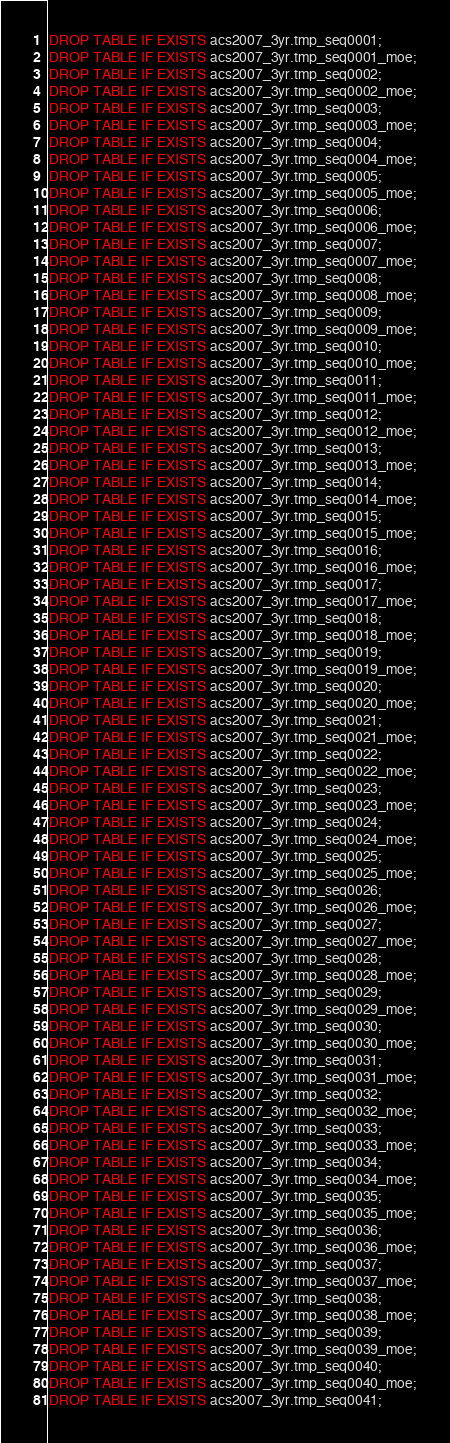<code> <loc_0><loc_0><loc_500><loc_500><_SQL_>DROP TABLE IF EXISTS acs2007_3yr.tmp_seq0001;
DROP TABLE IF EXISTS acs2007_3yr.tmp_seq0001_moe;
DROP TABLE IF EXISTS acs2007_3yr.tmp_seq0002;
DROP TABLE IF EXISTS acs2007_3yr.tmp_seq0002_moe;
DROP TABLE IF EXISTS acs2007_3yr.tmp_seq0003;
DROP TABLE IF EXISTS acs2007_3yr.tmp_seq0003_moe;
DROP TABLE IF EXISTS acs2007_3yr.tmp_seq0004;
DROP TABLE IF EXISTS acs2007_3yr.tmp_seq0004_moe;
DROP TABLE IF EXISTS acs2007_3yr.tmp_seq0005;
DROP TABLE IF EXISTS acs2007_3yr.tmp_seq0005_moe;
DROP TABLE IF EXISTS acs2007_3yr.tmp_seq0006;
DROP TABLE IF EXISTS acs2007_3yr.tmp_seq0006_moe;
DROP TABLE IF EXISTS acs2007_3yr.tmp_seq0007;
DROP TABLE IF EXISTS acs2007_3yr.tmp_seq0007_moe;
DROP TABLE IF EXISTS acs2007_3yr.tmp_seq0008;
DROP TABLE IF EXISTS acs2007_3yr.tmp_seq0008_moe;
DROP TABLE IF EXISTS acs2007_3yr.tmp_seq0009;
DROP TABLE IF EXISTS acs2007_3yr.tmp_seq0009_moe;
DROP TABLE IF EXISTS acs2007_3yr.tmp_seq0010;
DROP TABLE IF EXISTS acs2007_3yr.tmp_seq0010_moe;
DROP TABLE IF EXISTS acs2007_3yr.tmp_seq0011;
DROP TABLE IF EXISTS acs2007_3yr.tmp_seq0011_moe;
DROP TABLE IF EXISTS acs2007_3yr.tmp_seq0012;
DROP TABLE IF EXISTS acs2007_3yr.tmp_seq0012_moe;
DROP TABLE IF EXISTS acs2007_3yr.tmp_seq0013;
DROP TABLE IF EXISTS acs2007_3yr.tmp_seq0013_moe;
DROP TABLE IF EXISTS acs2007_3yr.tmp_seq0014;
DROP TABLE IF EXISTS acs2007_3yr.tmp_seq0014_moe;
DROP TABLE IF EXISTS acs2007_3yr.tmp_seq0015;
DROP TABLE IF EXISTS acs2007_3yr.tmp_seq0015_moe;
DROP TABLE IF EXISTS acs2007_3yr.tmp_seq0016;
DROP TABLE IF EXISTS acs2007_3yr.tmp_seq0016_moe;
DROP TABLE IF EXISTS acs2007_3yr.tmp_seq0017;
DROP TABLE IF EXISTS acs2007_3yr.tmp_seq0017_moe;
DROP TABLE IF EXISTS acs2007_3yr.tmp_seq0018;
DROP TABLE IF EXISTS acs2007_3yr.tmp_seq0018_moe;
DROP TABLE IF EXISTS acs2007_3yr.tmp_seq0019;
DROP TABLE IF EXISTS acs2007_3yr.tmp_seq0019_moe;
DROP TABLE IF EXISTS acs2007_3yr.tmp_seq0020;
DROP TABLE IF EXISTS acs2007_3yr.tmp_seq0020_moe;
DROP TABLE IF EXISTS acs2007_3yr.tmp_seq0021;
DROP TABLE IF EXISTS acs2007_3yr.tmp_seq0021_moe;
DROP TABLE IF EXISTS acs2007_3yr.tmp_seq0022;
DROP TABLE IF EXISTS acs2007_3yr.tmp_seq0022_moe;
DROP TABLE IF EXISTS acs2007_3yr.tmp_seq0023;
DROP TABLE IF EXISTS acs2007_3yr.tmp_seq0023_moe;
DROP TABLE IF EXISTS acs2007_3yr.tmp_seq0024;
DROP TABLE IF EXISTS acs2007_3yr.tmp_seq0024_moe;
DROP TABLE IF EXISTS acs2007_3yr.tmp_seq0025;
DROP TABLE IF EXISTS acs2007_3yr.tmp_seq0025_moe;
DROP TABLE IF EXISTS acs2007_3yr.tmp_seq0026;
DROP TABLE IF EXISTS acs2007_3yr.tmp_seq0026_moe;
DROP TABLE IF EXISTS acs2007_3yr.tmp_seq0027;
DROP TABLE IF EXISTS acs2007_3yr.tmp_seq0027_moe;
DROP TABLE IF EXISTS acs2007_3yr.tmp_seq0028;
DROP TABLE IF EXISTS acs2007_3yr.tmp_seq0028_moe;
DROP TABLE IF EXISTS acs2007_3yr.tmp_seq0029;
DROP TABLE IF EXISTS acs2007_3yr.tmp_seq0029_moe;
DROP TABLE IF EXISTS acs2007_3yr.tmp_seq0030;
DROP TABLE IF EXISTS acs2007_3yr.tmp_seq0030_moe;
DROP TABLE IF EXISTS acs2007_3yr.tmp_seq0031;
DROP TABLE IF EXISTS acs2007_3yr.tmp_seq0031_moe;
DROP TABLE IF EXISTS acs2007_3yr.tmp_seq0032;
DROP TABLE IF EXISTS acs2007_3yr.tmp_seq0032_moe;
DROP TABLE IF EXISTS acs2007_3yr.tmp_seq0033;
DROP TABLE IF EXISTS acs2007_3yr.tmp_seq0033_moe;
DROP TABLE IF EXISTS acs2007_3yr.tmp_seq0034;
DROP TABLE IF EXISTS acs2007_3yr.tmp_seq0034_moe;
DROP TABLE IF EXISTS acs2007_3yr.tmp_seq0035;
DROP TABLE IF EXISTS acs2007_3yr.tmp_seq0035_moe;
DROP TABLE IF EXISTS acs2007_3yr.tmp_seq0036;
DROP TABLE IF EXISTS acs2007_3yr.tmp_seq0036_moe;
DROP TABLE IF EXISTS acs2007_3yr.tmp_seq0037;
DROP TABLE IF EXISTS acs2007_3yr.tmp_seq0037_moe;
DROP TABLE IF EXISTS acs2007_3yr.tmp_seq0038;
DROP TABLE IF EXISTS acs2007_3yr.tmp_seq0038_moe;
DROP TABLE IF EXISTS acs2007_3yr.tmp_seq0039;
DROP TABLE IF EXISTS acs2007_3yr.tmp_seq0039_moe;
DROP TABLE IF EXISTS acs2007_3yr.tmp_seq0040;
DROP TABLE IF EXISTS acs2007_3yr.tmp_seq0040_moe;
DROP TABLE IF EXISTS acs2007_3yr.tmp_seq0041;</code> 